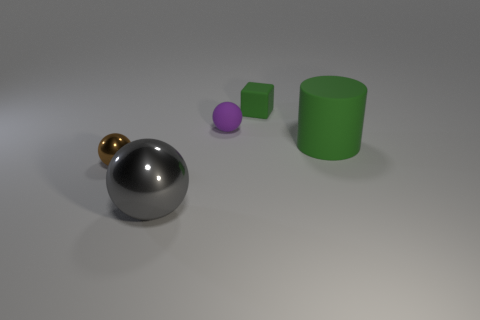Is the size of the green rubber thing that is behind the rubber ball the same as the big gray metallic sphere? The green rubber object appears to be significantly smaller in size when compared to the larger gray metallic sphere at the forefront of the image. 